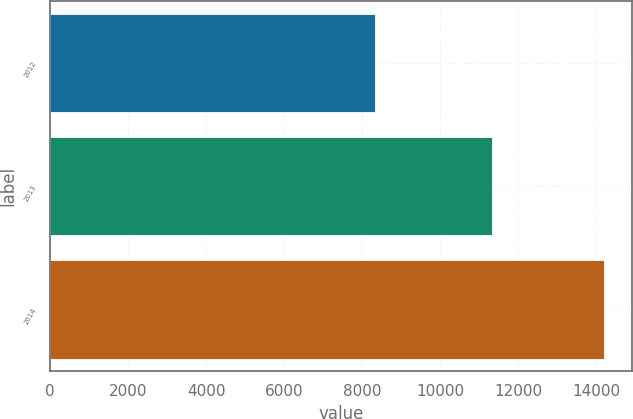<chart> <loc_0><loc_0><loc_500><loc_500><bar_chart><fcel>2012<fcel>2013<fcel>2014<nl><fcel>8323<fcel>11321<fcel>14209<nl></chart> 